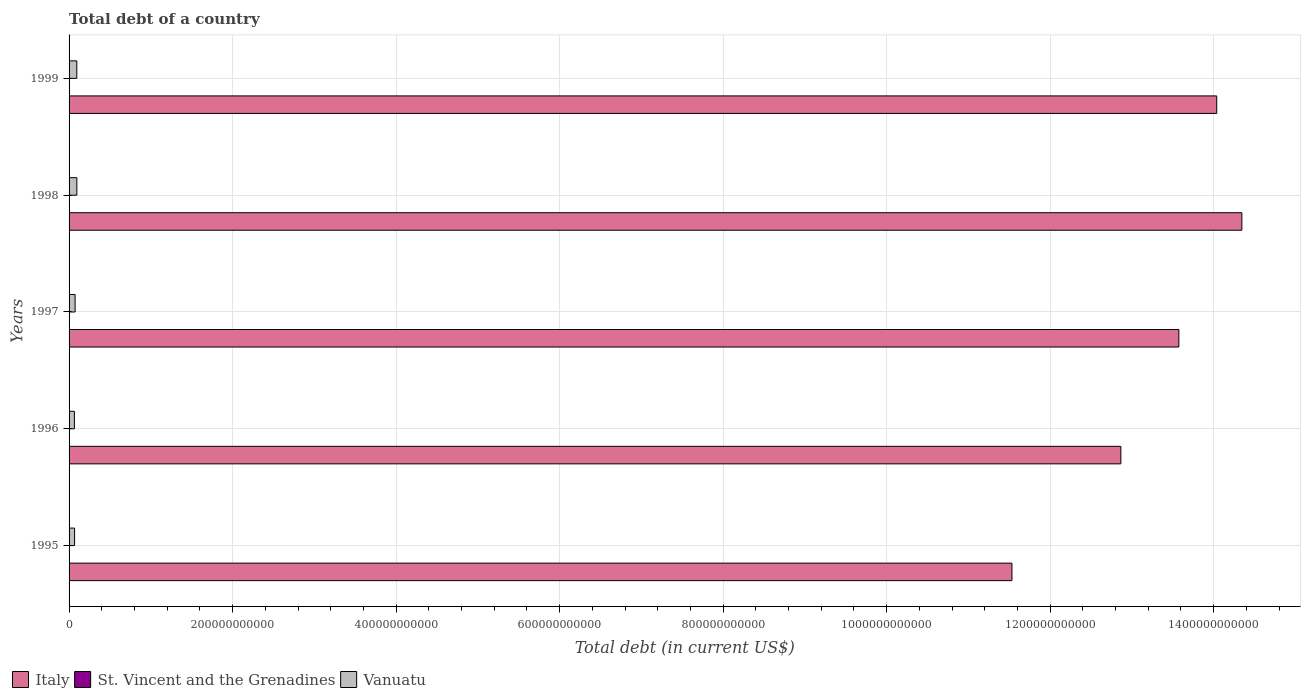How many different coloured bars are there?
Ensure brevity in your answer.  3. Are the number of bars on each tick of the Y-axis equal?
Make the answer very short. Yes. How many bars are there on the 5th tick from the bottom?
Keep it short and to the point. 3. In how many cases, is the number of bars for a given year not equal to the number of legend labels?
Provide a short and direct response. 0. What is the debt in Italy in 1997?
Your response must be concise. 1.36e+12. Across all years, what is the maximum debt in Italy?
Your response must be concise. 1.43e+12. Across all years, what is the minimum debt in St. Vincent and the Grenadines?
Provide a succinct answer. 3.70e+08. In which year was the debt in Italy maximum?
Your response must be concise. 1998. In which year was the debt in St. Vincent and the Grenadines minimum?
Provide a short and direct response. 1997. What is the total debt in St. Vincent and the Grenadines in the graph?
Your response must be concise. 2.06e+09. What is the difference between the debt in Vanuatu in 1996 and that in 1999?
Provide a short and direct response. -2.92e+09. What is the difference between the debt in Vanuatu in 1996 and the debt in Italy in 1997?
Offer a terse response. -1.35e+12. What is the average debt in Italy per year?
Your response must be concise. 1.33e+12. In the year 1996, what is the difference between the debt in Vanuatu and debt in St. Vincent and the Grenadines?
Provide a succinct answer. 6.15e+09. In how many years, is the debt in Italy greater than 480000000000 US$?
Ensure brevity in your answer.  5. What is the ratio of the debt in Italy in 1997 to that in 1999?
Provide a succinct answer. 0.97. Is the difference between the debt in Vanuatu in 1997 and 1999 greater than the difference between the debt in St. Vincent and the Grenadines in 1997 and 1999?
Ensure brevity in your answer.  No. What is the difference between the highest and the second highest debt in St. Vincent and the Grenadines?
Give a very brief answer. 1.44e+08. What is the difference between the highest and the lowest debt in Italy?
Offer a terse response. 2.81e+11. In how many years, is the debt in St. Vincent and the Grenadines greater than the average debt in St. Vincent and the Grenadines taken over all years?
Your response must be concise. 1. What does the 3rd bar from the top in 1998 represents?
Offer a very short reply. Italy. What does the 2nd bar from the bottom in 1997 represents?
Ensure brevity in your answer.  St. Vincent and the Grenadines. Is it the case that in every year, the sum of the debt in St. Vincent and the Grenadines and debt in Italy is greater than the debt in Vanuatu?
Ensure brevity in your answer.  Yes. How many bars are there?
Offer a terse response. 15. How many years are there in the graph?
Keep it short and to the point. 5. What is the difference between two consecutive major ticks on the X-axis?
Make the answer very short. 2.00e+11. Are the values on the major ticks of X-axis written in scientific E-notation?
Provide a short and direct response. No. Does the graph contain any zero values?
Provide a succinct answer. No. Does the graph contain grids?
Your response must be concise. Yes. How many legend labels are there?
Keep it short and to the point. 3. What is the title of the graph?
Keep it short and to the point. Total debt of a country. What is the label or title of the X-axis?
Keep it short and to the point. Total debt (in current US$). What is the label or title of the Y-axis?
Your response must be concise. Years. What is the Total debt (in current US$) of Italy in 1995?
Ensure brevity in your answer.  1.15e+12. What is the Total debt (in current US$) in St. Vincent and the Grenadines in 1995?
Make the answer very short. 3.70e+08. What is the Total debt (in current US$) in Vanuatu in 1995?
Your answer should be very brief. 6.76e+09. What is the Total debt (in current US$) of Italy in 1996?
Offer a terse response. 1.29e+12. What is the Total debt (in current US$) of St. Vincent and the Grenadines in 1996?
Offer a very short reply. 3.72e+08. What is the Total debt (in current US$) of Vanuatu in 1996?
Offer a terse response. 6.52e+09. What is the Total debt (in current US$) of Italy in 1997?
Your answer should be compact. 1.36e+12. What is the Total debt (in current US$) in St. Vincent and the Grenadines in 1997?
Give a very brief answer. 3.70e+08. What is the Total debt (in current US$) in Vanuatu in 1997?
Offer a terse response. 7.38e+09. What is the Total debt (in current US$) in Italy in 1998?
Provide a short and direct response. 1.43e+12. What is the Total debt (in current US$) of St. Vincent and the Grenadines in 1998?
Provide a succinct answer. 4.04e+08. What is the Total debt (in current US$) in Vanuatu in 1998?
Your answer should be very brief. 9.50e+09. What is the Total debt (in current US$) of Italy in 1999?
Your response must be concise. 1.40e+12. What is the Total debt (in current US$) of St. Vincent and the Grenadines in 1999?
Provide a succinct answer. 5.48e+08. What is the Total debt (in current US$) in Vanuatu in 1999?
Your response must be concise. 9.44e+09. Across all years, what is the maximum Total debt (in current US$) of Italy?
Provide a short and direct response. 1.43e+12. Across all years, what is the maximum Total debt (in current US$) in St. Vincent and the Grenadines?
Your response must be concise. 5.48e+08. Across all years, what is the maximum Total debt (in current US$) of Vanuatu?
Your answer should be very brief. 9.50e+09. Across all years, what is the minimum Total debt (in current US$) in Italy?
Your answer should be very brief. 1.15e+12. Across all years, what is the minimum Total debt (in current US$) of St. Vincent and the Grenadines?
Provide a short and direct response. 3.70e+08. Across all years, what is the minimum Total debt (in current US$) in Vanuatu?
Offer a very short reply. 6.52e+09. What is the total Total debt (in current US$) in Italy in the graph?
Offer a very short reply. 6.64e+12. What is the total Total debt (in current US$) of St. Vincent and the Grenadines in the graph?
Offer a terse response. 2.06e+09. What is the total Total debt (in current US$) of Vanuatu in the graph?
Make the answer very short. 3.96e+1. What is the difference between the Total debt (in current US$) of Italy in 1995 and that in 1996?
Give a very brief answer. -1.33e+11. What is the difference between the Total debt (in current US$) of St. Vincent and the Grenadines in 1995 and that in 1996?
Your answer should be very brief. -2.50e+06. What is the difference between the Total debt (in current US$) of Vanuatu in 1995 and that in 1996?
Ensure brevity in your answer.  2.37e+08. What is the difference between the Total debt (in current US$) of Italy in 1995 and that in 1997?
Provide a short and direct response. -2.04e+11. What is the difference between the Total debt (in current US$) in St. Vincent and the Grenadines in 1995 and that in 1997?
Ensure brevity in your answer.  1.00e+05. What is the difference between the Total debt (in current US$) of Vanuatu in 1995 and that in 1997?
Provide a succinct answer. -6.21e+08. What is the difference between the Total debt (in current US$) in Italy in 1995 and that in 1998?
Provide a short and direct response. -2.81e+11. What is the difference between the Total debt (in current US$) in St. Vincent and the Grenadines in 1995 and that in 1998?
Provide a succinct answer. -3.40e+07. What is the difference between the Total debt (in current US$) of Vanuatu in 1995 and that in 1998?
Provide a short and direct response. -2.74e+09. What is the difference between the Total debt (in current US$) in Italy in 1995 and that in 1999?
Your answer should be compact. -2.50e+11. What is the difference between the Total debt (in current US$) of St. Vincent and the Grenadines in 1995 and that in 1999?
Provide a short and direct response. -1.78e+08. What is the difference between the Total debt (in current US$) of Vanuatu in 1995 and that in 1999?
Your response must be concise. -2.68e+09. What is the difference between the Total debt (in current US$) of Italy in 1996 and that in 1997?
Your answer should be compact. -7.09e+1. What is the difference between the Total debt (in current US$) of St. Vincent and the Grenadines in 1996 and that in 1997?
Keep it short and to the point. 2.60e+06. What is the difference between the Total debt (in current US$) of Vanuatu in 1996 and that in 1997?
Keep it short and to the point. -8.58e+08. What is the difference between the Total debt (in current US$) in Italy in 1996 and that in 1998?
Your response must be concise. -1.48e+11. What is the difference between the Total debt (in current US$) of St. Vincent and the Grenadines in 1996 and that in 1998?
Your answer should be very brief. -3.15e+07. What is the difference between the Total debt (in current US$) in Vanuatu in 1996 and that in 1998?
Ensure brevity in your answer.  -2.98e+09. What is the difference between the Total debt (in current US$) in Italy in 1996 and that in 1999?
Offer a terse response. -1.17e+11. What is the difference between the Total debt (in current US$) of St. Vincent and the Grenadines in 1996 and that in 1999?
Your answer should be compact. -1.76e+08. What is the difference between the Total debt (in current US$) in Vanuatu in 1996 and that in 1999?
Keep it short and to the point. -2.92e+09. What is the difference between the Total debt (in current US$) of Italy in 1997 and that in 1998?
Offer a very short reply. -7.70e+1. What is the difference between the Total debt (in current US$) in St. Vincent and the Grenadines in 1997 and that in 1998?
Your response must be concise. -3.41e+07. What is the difference between the Total debt (in current US$) of Vanuatu in 1997 and that in 1998?
Make the answer very short. -2.12e+09. What is the difference between the Total debt (in current US$) of Italy in 1997 and that in 1999?
Your response must be concise. -4.63e+1. What is the difference between the Total debt (in current US$) of St. Vincent and the Grenadines in 1997 and that in 1999?
Keep it short and to the point. -1.78e+08. What is the difference between the Total debt (in current US$) in Vanuatu in 1997 and that in 1999?
Offer a terse response. -2.06e+09. What is the difference between the Total debt (in current US$) in Italy in 1998 and that in 1999?
Provide a short and direct response. 3.07e+1. What is the difference between the Total debt (in current US$) in St. Vincent and the Grenadines in 1998 and that in 1999?
Make the answer very short. -1.44e+08. What is the difference between the Total debt (in current US$) in Vanuatu in 1998 and that in 1999?
Your answer should be compact. 5.50e+07. What is the difference between the Total debt (in current US$) of Italy in 1995 and the Total debt (in current US$) of St. Vincent and the Grenadines in 1996?
Offer a terse response. 1.15e+12. What is the difference between the Total debt (in current US$) in Italy in 1995 and the Total debt (in current US$) in Vanuatu in 1996?
Provide a succinct answer. 1.15e+12. What is the difference between the Total debt (in current US$) of St. Vincent and the Grenadines in 1995 and the Total debt (in current US$) of Vanuatu in 1996?
Give a very brief answer. -6.15e+09. What is the difference between the Total debt (in current US$) of Italy in 1995 and the Total debt (in current US$) of St. Vincent and the Grenadines in 1997?
Your answer should be compact. 1.15e+12. What is the difference between the Total debt (in current US$) of Italy in 1995 and the Total debt (in current US$) of Vanuatu in 1997?
Provide a succinct answer. 1.15e+12. What is the difference between the Total debt (in current US$) of St. Vincent and the Grenadines in 1995 and the Total debt (in current US$) of Vanuatu in 1997?
Ensure brevity in your answer.  -7.01e+09. What is the difference between the Total debt (in current US$) of Italy in 1995 and the Total debt (in current US$) of St. Vincent and the Grenadines in 1998?
Offer a terse response. 1.15e+12. What is the difference between the Total debt (in current US$) of Italy in 1995 and the Total debt (in current US$) of Vanuatu in 1998?
Your response must be concise. 1.14e+12. What is the difference between the Total debt (in current US$) of St. Vincent and the Grenadines in 1995 and the Total debt (in current US$) of Vanuatu in 1998?
Make the answer very short. -9.13e+09. What is the difference between the Total debt (in current US$) in Italy in 1995 and the Total debt (in current US$) in St. Vincent and the Grenadines in 1999?
Provide a short and direct response. 1.15e+12. What is the difference between the Total debt (in current US$) in Italy in 1995 and the Total debt (in current US$) in Vanuatu in 1999?
Keep it short and to the point. 1.14e+12. What is the difference between the Total debt (in current US$) of St. Vincent and the Grenadines in 1995 and the Total debt (in current US$) of Vanuatu in 1999?
Your answer should be very brief. -9.08e+09. What is the difference between the Total debt (in current US$) of Italy in 1996 and the Total debt (in current US$) of St. Vincent and the Grenadines in 1997?
Your answer should be compact. 1.29e+12. What is the difference between the Total debt (in current US$) in Italy in 1996 and the Total debt (in current US$) in Vanuatu in 1997?
Keep it short and to the point. 1.28e+12. What is the difference between the Total debt (in current US$) in St. Vincent and the Grenadines in 1996 and the Total debt (in current US$) in Vanuatu in 1997?
Offer a very short reply. -7.01e+09. What is the difference between the Total debt (in current US$) in Italy in 1996 and the Total debt (in current US$) in St. Vincent and the Grenadines in 1998?
Make the answer very short. 1.29e+12. What is the difference between the Total debt (in current US$) of Italy in 1996 and the Total debt (in current US$) of Vanuatu in 1998?
Your response must be concise. 1.28e+12. What is the difference between the Total debt (in current US$) in St. Vincent and the Grenadines in 1996 and the Total debt (in current US$) in Vanuatu in 1998?
Offer a very short reply. -9.13e+09. What is the difference between the Total debt (in current US$) in Italy in 1996 and the Total debt (in current US$) in St. Vincent and the Grenadines in 1999?
Ensure brevity in your answer.  1.29e+12. What is the difference between the Total debt (in current US$) of Italy in 1996 and the Total debt (in current US$) of Vanuatu in 1999?
Give a very brief answer. 1.28e+12. What is the difference between the Total debt (in current US$) of St. Vincent and the Grenadines in 1996 and the Total debt (in current US$) of Vanuatu in 1999?
Ensure brevity in your answer.  -9.07e+09. What is the difference between the Total debt (in current US$) of Italy in 1997 and the Total debt (in current US$) of St. Vincent and the Grenadines in 1998?
Ensure brevity in your answer.  1.36e+12. What is the difference between the Total debt (in current US$) of Italy in 1997 and the Total debt (in current US$) of Vanuatu in 1998?
Keep it short and to the point. 1.35e+12. What is the difference between the Total debt (in current US$) in St. Vincent and the Grenadines in 1997 and the Total debt (in current US$) in Vanuatu in 1998?
Keep it short and to the point. -9.13e+09. What is the difference between the Total debt (in current US$) in Italy in 1997 and the Total debt (in current US$) in St. Vincent and the Grenadines in 1999?
Ensure brevity in your answer.  1.36e+12. What is the difference between the Total debt (in current US$) of Italy in 1997 and the Total debt (in current US$) of Vanuatu in 1999?
Your answer should be very brief. 1.35e+12. What is the difference between the Total debt (in current US$) in St. Vincent and the Grenadines in 1997 and the Total debt (in current US$) in Vanuatu in 1999?
Your answer should be compact. -9.08e+09. What is the difference between the Total debt (in current US$) of Italy in 1998 and the Total debt (in current US$) of St. Vincent and the Grenadines in 1999?
Provide a succinct answer. 1.43e+12. What is the difference between the Total debt (in current US$) of Italy in 1998 and the Total debt (in current US$) of Vanuatu in 1999?
Your answer should be very brief. 1.43e+12. What is the difference between the Total debt (in current US$) in St. Vincent and the Grenadines in 1998 and the Total debt (in current US$) in Vanuatu in 1999?
Offer a very short reply. -9.04e+09. What is the average Total debt (in current US$) in Italy per year?
Your answer should be compact. 1.33e+12. What is the average Total debt (in current US$) of St. Vincent and the Grenadines per year?
Your answer should be compact. 4.13e+08. What is the average Total debt (in current US$) in Vanuatu per year?
Give a very brief answer. 7.92e+09. In the year 1995, what is the difference between the Total debt (in current US$) of Italy and Total debt (in current US$) of St. Vincent and the Grenadines?
Provide a short and direct response. 1.15e+12. In the year 1995, what is the difference between the Total debt (in current US$) of Italy and Total debt (in current US$) of Vanuatu?
Keep it short and to the point. 1.15e+12. In the year 1995, what is the difference between the Total debt (in current US$) in St. Vincent and the Grenadines and Total debt (in current US$) in Vanuatu?
Offer a very short reply. -6.39e+09. In the year 1996, what is the difference between the Total debt (in current US$) in Italy and Total debt (in current US$) in St. Vincent and the Grenadines?
Provide a succinct answer. 1.29e+12. In the year 1996, what is the difference between the Total debt (in current US$) in Italy and Total debt (in current US$) in Vanuatu?
Give a very brief answer. 1.28e+12. In the year 1996, what is the difference between the Total debt (in current US$) in St. Vincent and the Grenadines and Total debt (in current US$) in Vanuatu?
Provide a short and direct response. -6.15e+09. In the year 1997, what is the difference between the Total debt (in current US$) in Italy and Total debt (in current US$) in St. Vincent and the Grenadines?
Your response must be concise. 1.36e+12. In the year 1997, what is the difference between the Total debt (in current US$) in Italy and Total debt (in current US$) in Vanuatu?
Provide a succinct answer. 1.35e+12. In the year 1997, what is the difference between the Total debt (in current US$) of St. Vincent and the Grenadines and Total debt (in current US$) of Vanuatu?
Offer a terse response. -7.01e+09. In the year 1998, what is the difference between the Total debt (in current US$) of Italy and Total debt (in current US$) of St. Vincent and the Grenadines?
Offer a terse response. 1.43e+12. In the year 1998, what is the difference between the Total debt (in current US$) in Italy and Total debt (in current US$) in Vanuatu?
Your answer should be very brief. 1.42e+12. In the year 1998, what is the difference between the Total debt (in current US$) of St. Vincent and the Grenadines and Total debt (in current US$) of Vanuatu?
Keep it short and to the point. -9.10e+09. In the year 1999, what is the difference between the Total debt (in current US$) in Italy and Total debt (in current US$) in St. Vincent and the Grenadines?
Provide a short and direct response. 1.40e+12. In the year 1999, what is the difference between the Total debt (in current US$) of Italy and Total debt (in current US$) of Vanuatu?
Ensure brevity in your answer.  1.39e+12. In the year 1999, what is the difference between the Total debt (in current US$) in St. Vincent and the Grenadines and Total debt (in current US$) in Vanuatu?
Give a very brief answer. -8.90e+09. What is the ratio of the Total debt (in current US$) of Italy in 1995 to that in 1996?
Offer a terse response. 0.9. What is the ratio of the Total debt (in current US$) of Vanuatu in 1995 to that in 1996?
Your answer should be compact. 1.04. What is the ratio of the Total debt (in current US$) of Italy in 1995 to that in 1997?
Your answer should be compact. 0.85. What is the ratio of the Total debt (in current US$) in St. Vincent and the Grenadines in 1995 to that in 1997?
Keep it short and to the point. 1. What is the ratio of the Total debt (in current US$) of Vanuatu in 1995 to that in 1997?
Your answer should be very brief. 0.92. What is the ratio of the Total debt (in current US$) in Italy in 1995 to that in 1998?
Ensure brevity in your answer.  0.8. What is the ratio of the Total debt (in current US$) of St. Vincent and the Grenadines in 1995 to that in 1998?
Your answer should be very brief. 0.92. What is the ratio of the Total debt (in current US$) of Vanuatu in 1995 to that in 1998?
Your answer should be very brief. 0.71. What is the ratio of the Total debt (in current US$) of Italy in 1995 to that in 1999?
Your answer should be very brief. 0.82. What is the ratio of the Total debt (in current US$) in St. Vincent and the Grenadines in 1995 to that in 1999?
Offer a very short reply. 0.68. What is the ratio of the Total debt (in current US$) of Vanuatu in 1995 to that in 1999?
Give a very brief answer. 0.72. What is the ratio of the Total debt (in current US$) of Italy in 1996 to that in 1997?
Your answer should be very brief. 0.95. What is the ratio of the Total debt (in current US$) in St. Vincent and the Grenadines in 1996 to that in 1997?
Your answer should be very brief. 1.01. What is the ratio of the Total debt (in current US$) in Vanuatu in 1996 to that in 1997?
Provide a succinct answer. 0.88. What is the ratio of the Total debt (in current US$) of Italy in 1996 to that in 1998?
Provide a short and direct response. 0.9. What is the ratio of the Total debt (in current US$) in St. Vincent and the Grenadines in 1996 to that in 1998?
Make the answer very short. 0.92. What is the ratio of the Total debt (in current US$) in Vanuatu in 1996 to that in 1998?
Your answer should be compact. 0.69. What is the ratio of the Total debt (in current US$) in Italy in 1996 to that in 1999?
Provide a succinct answer. 0.92. What is the ratio of the Total debt (in current US$) in St. Vincent and the Grenadines in 1996 to that in 1999?
Your response must be concise. 0.68. What is the ratio of the Total debt (in current US$) of Vanuatu in 1996 to that in 1999?
Make the answer very short. 0.69. What is the ratio of the Total debt (in current US$) in Italy in 1997 to that in 1998?
Provide a succinct answer. 0.95. What is the ratio of the Total debt (in current US$) of St. Vincent and the Grenadines in 1997 to that in 1998?
Give a very brief answer. 0.92. What is the ratio of the Total debt (in current US$) of Vanuatu in 1997 to that in 1998?
Make the answer very short. 0.78. What is the ratio of the Total debt (in current US$) of St. Vincent and the Grenadines in 1997 to that in 1999?
Ensure brevity in your answer.  0.67. What is the ratio of the Total debt (in current US$) in Vanuatu in 1997 to that in 1999?
Provide a short and direct response. 0.78. What is the ratio of the Total debt (in current US$) of Italy in 1998 to that in 1999?
Provide a short and direct response. 1.02. What is the ratio of the Total debt (in current US$) of St. Vincent and the Grenadines in 1998 to that in 1999?
Provide a succinct answer. 0.74. What is the difference between the highest and the second highest Total debt (in current US$) in Italy?
Offer a very short reply. 3.07e+1. What is the difference between the highest and the second highest Total debt (in current US$) in St. Vincent and the Grenadines?
Provide a succinct answer. 1.44e+08. What is the difference between the highest and the second highest Total debt (in current US$) of Vanuatu?
Your answer should be compact. 5.50e+07. What is the difference between the highest and the lowest Total debt (in current US$) in Italy?
Offer a very short reply. 2.81e+11. What is the difference between the highest and the lowest Total debt (in current US$) in St. Vincent and the Grenadines?
Provide a succinct answer. 1.78e+08. What is the difference between the highest and the lowest Total debt (in current US$) in Vanuatu?
Make the answer very short. 2.98e+09. 